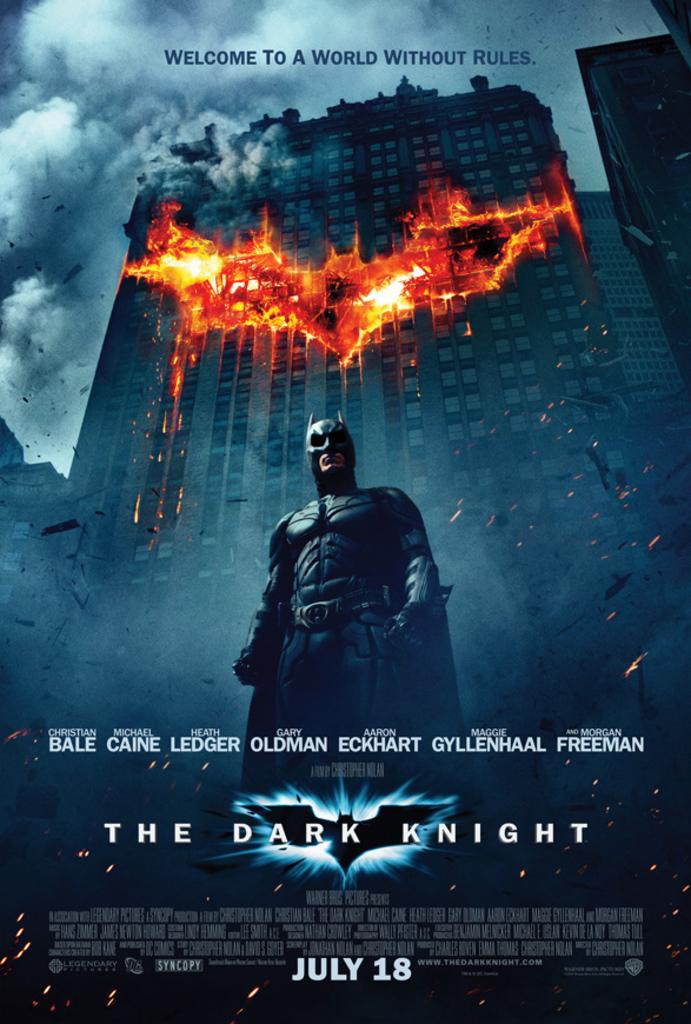What is the film title?
Offer a terse response. The dark knight. 